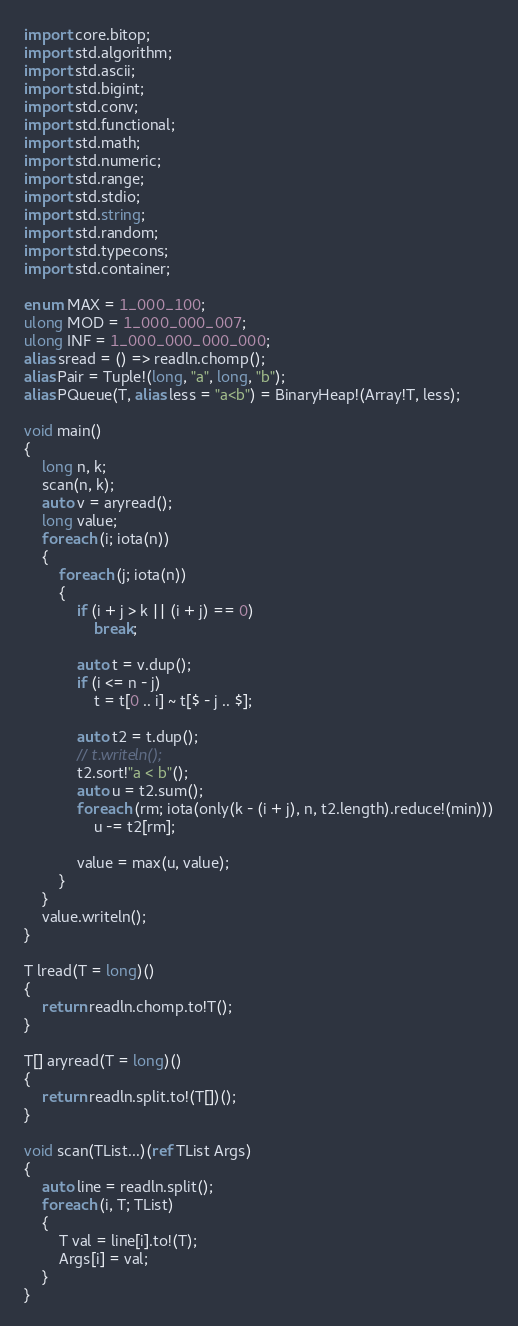Convert code to text. <code><loc_0><loc_0><loc_500><loc_500><_D_>import core.bitop;
import std.algorithm;
import std.ascii;
import std.bigint;
import std.conv;
import std.functional;
import std.math;
import std.numeric;
import std.range;
import std.stdio;
import std.string;
import std.random;
import std.typecons;
import std.container;

enum MAX = 1_000_100;
ulong MOD = 1_000_000_007;
ulong INF = 1_000_000_000_000;
alias sread = () => readln.chomp();
alias Pair = Tuple!(long, "a", long, "b");
alias PQueue(T, alias less = "a<b") = BinaryHeap!(Array!T, less);

void main()
{
    long n, k;
    scan(n, k);
    auto v = aryread();
    long value;
    foreach (i; iota(n))
    {
        foreach (j; iota(n))
        {
            if (i + j > k || (i + j) == 0)
                break;

            auto t = v.dup();
            if (i <= n - j)
                t = t[0 .. i] ~ t[$ - j .. $];
                
            auto t2 = t.dup();
            // t.writeln();
            t2.sort!"a < b"();
            auto u = t2.sum();
            foreach (rm; iota(only(k - (i + j), n, t2.length).reduce!(min)))
                u -= t2[rm];

            value = max(u, value);
        }
    }
    value.writeln();
}

T lread(T = long)()
{
    return readln.chomp.to!T();
}

T[] aryread(T = long)()
{
    return readln.split.to!(T[])();
}

void scan(TList...)(ref TList Args)
{
    auto line = readln.split();
    foreach (i, T; TList)
    {
        T val = line[i].to!(T);
        Args[i] = val;
    }
}
</code> 